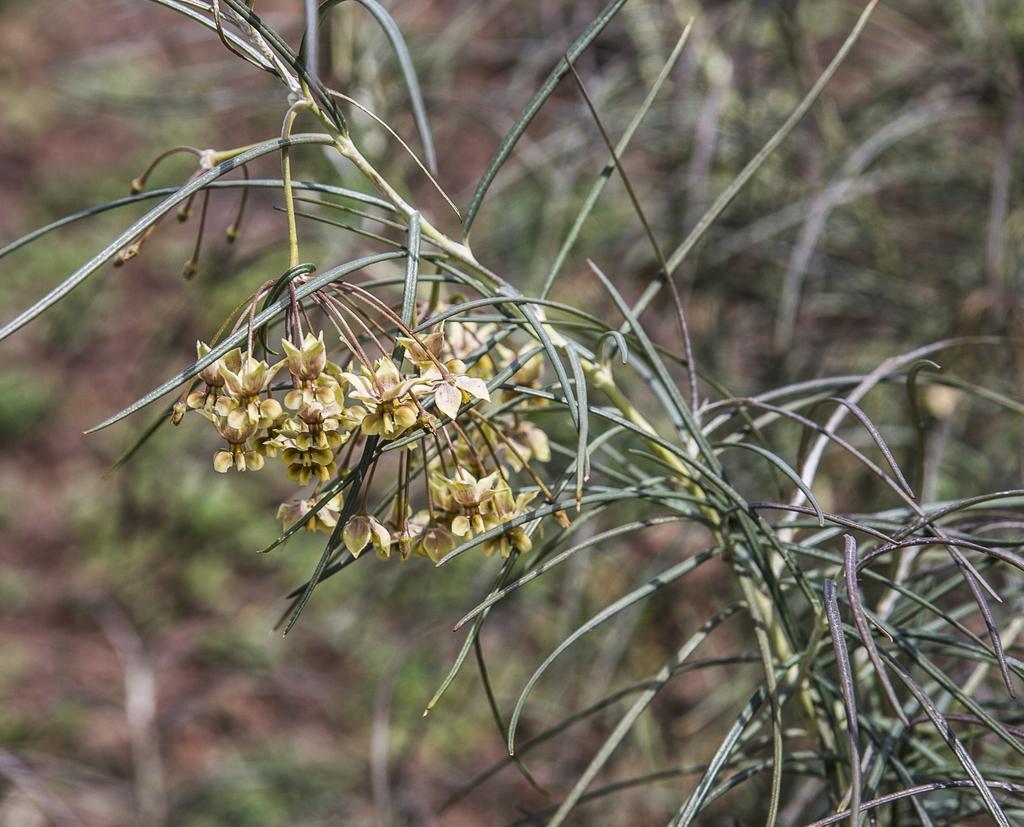Please provide a concise description of this image. In this image we can see many flowers to a plant. There is a blur background in the image. 